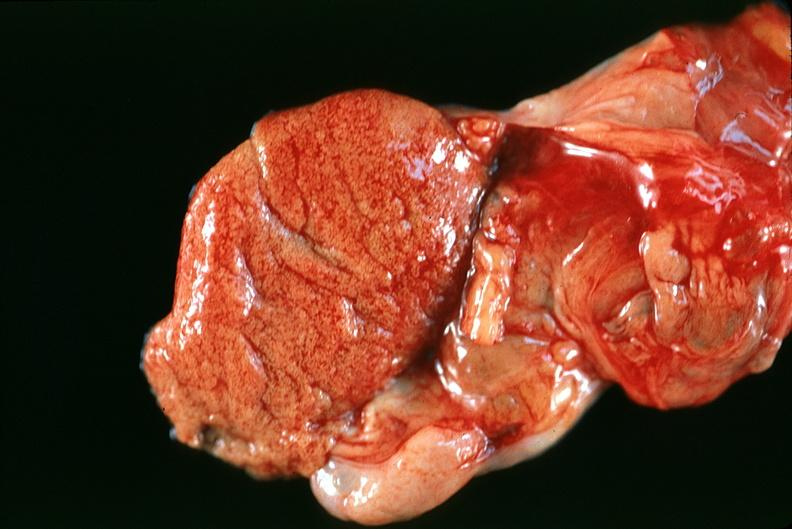s male reproductive present?
Answer the question using a single word or phrase. Yes 